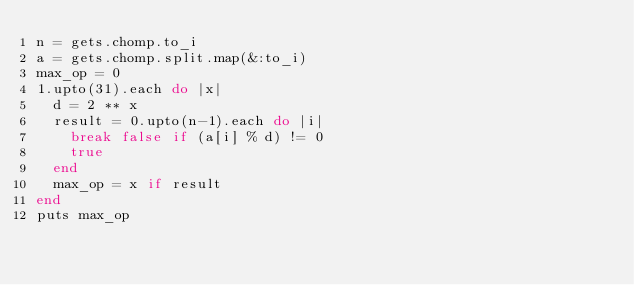<code> <loc_0><loc_0><loc_500><loc_500><_Ruby_>n = gets.chomp.to_i
a = gets.chomp.split.map(&:to_i)
max_op = 0
1.upto(31).each do |x|
  d = 2 ** x
  result = 0.upto(n-1).each do |i|
    break false if (a[i] % d) != 0
    true
  end
  max_op = x if result
end
puts max_op</code> 